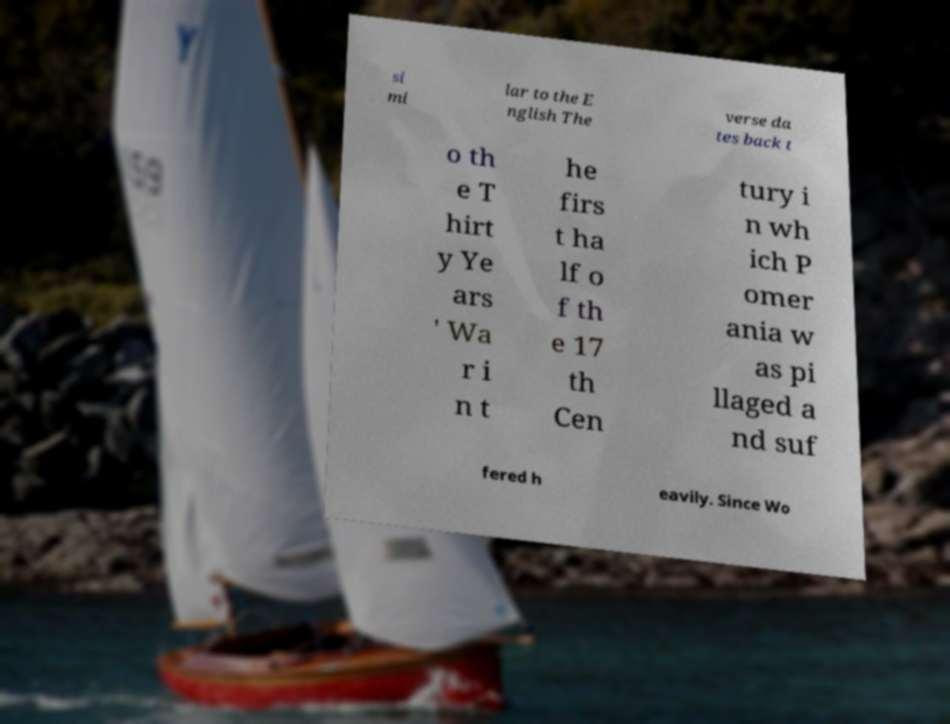Please read and relay the text visible in this image. What does it say? si mi lar to the E nglish The verse da tes back t o th e T hirt y Ye ars ' Wa r i n t he firs t ha lf o f th e 17 th Cen tury i n wh ich P omer ania w as pi llaged a nd suf fered h eavily. Since Wo 